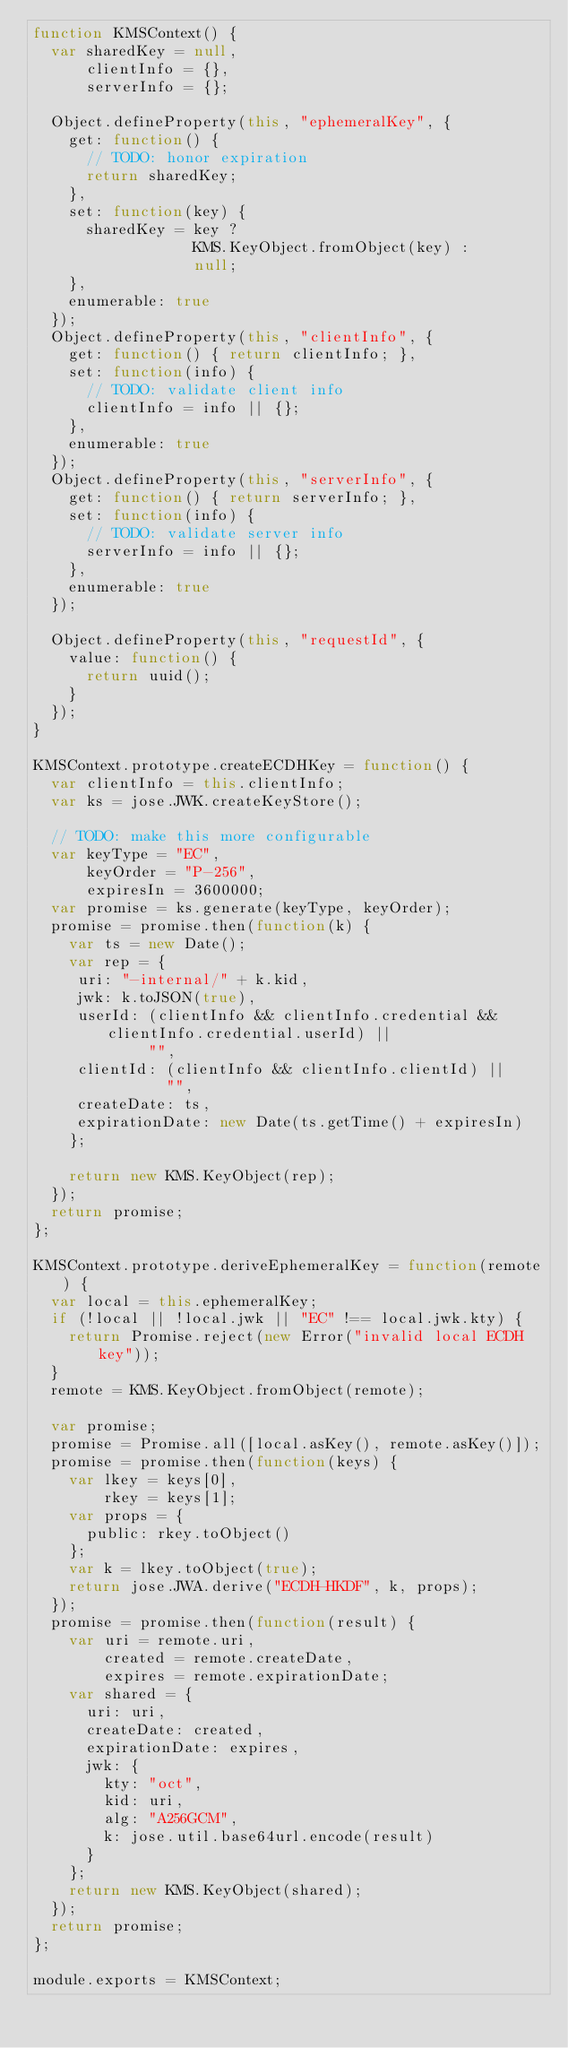Convert code to text. <code><loc_0><loc_0><loc_500><loc_500><_JavaScript_>function KMSContext() {
  var sharedKey = null,
      clientInfo = {},
      serverInfo = {};

  Object.defineProperty(this, "ephemeralKey", {
    get: function() {
      // TODO: honor expiration
      return sharedKey;
    },
    set: function(key) {
      sharedKey = key ?
                  KMS.KeyObject.fromObject(key) :
                  null;
    },
    enumerable: true
  });
  Object.defineProperty(this, "clientInfo", {
    get: function() { return clientInfo; },
    set: function(info) {
      // TODO: validate client info
      clientInfo = info || {};
    },
    enumerable: true
  });
  Object.defineProperty(this, "serverInfo", {
    get: function() { return serverInfo; },
    set: function(info) {
      // TODO: validate server info
      serverInfo = info || {};
    },
    enumerable: true
  });

  Object.defineProperty(this, "requestId", {
    value: function() {
      return uuid();
    }
  });
}

KMSContext.prototype.createECDHKey = function() {
  var clientInfo = this.clientInfo;
  var ks = jose.JWK.createKeyStore();

  // TODO: make this more configurable
  var keyType = "EC",
      keyOrder = "P-256",
      expiresIn = 3600000;
  var promise = ks.generate(keyType, keyOrder);
  promise = promise.then(function(k) {
    var ts = new Date();
    var rep = {
     uri: "-internal/" + k.kid,
     jwk: k.toJSON(true),
     userId: (clientInfo && clientInfo.credential && clientInfo.credential.userId) ||
             "",
     clientId: (clientInfo && clientInfo.clientId) ||
               "",
     createDate: ts,
     expirationDate: new Date(ts.getTime() + expiresIn)
    };

    return new KMS.KeyObject(rep);
  });
  return promise;
};

KMSContext.prototype.deriveEphemeralKey = function(remote) {
  var local = this.ephemeralKey;
  if (!local || !local.jwk || "EC" !== local.jwk.kty) {
    return Promise.reject(new Error("invalid local ECDH key"));
  }
  remote = KMS.KeyObject.fromObject(remote);

  var promise;
  promise = Promise.all([local.asKey(), remote.asKey()]);
  promise = promise.then(function(keys) {
    var lkey = keys[0],
        rkey = keys[1];
    var props = {
      public: rkey.toObject()
    };
    var k = lkey.toObject(true);
    return jose.JWA.derive("ECDH-HKDF", k, props);
  });
  promise = promise.then(function(result) {
    var uri = remote.uri,
        created = remote.createDate,
        expires = remote.expirationDate;
    var shared = {
      uri: uri,
      createDate: created,
      expirationDate: expires,
      jwk: {
        kty: "oct",
        kid: uri,
        alg: "A256GCM",
        k: jose.util.base64url.encode(result)
      }
    };
    return new KMS.KeyObject(shared);
  });
  return promise;
};

module.exports = KMSContext;
</code> 